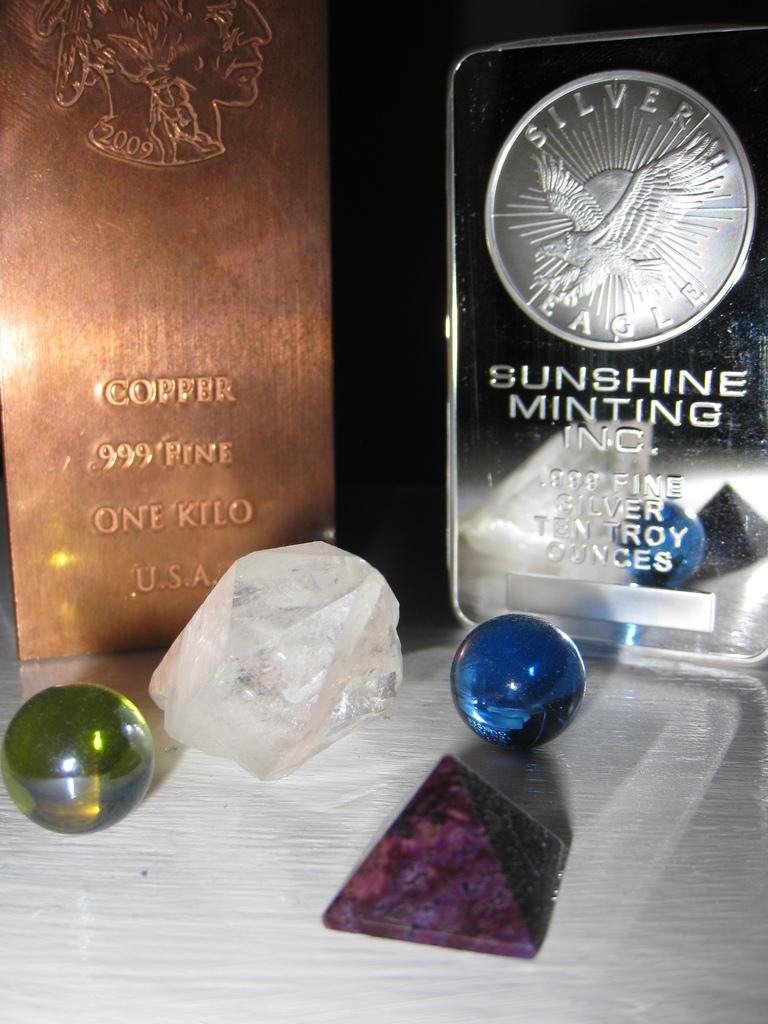<image>
Offer a succinct explanation of the picture presented. Marbles and stones in front of a box which says "Sunshine Minting Inc". 